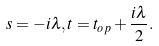<formula> <loc_0><loc_0><loc_500><loc_500>s = - i \lambda , t = t _ { o p } + \frac { i \lambda } { 2 } .</formula> 